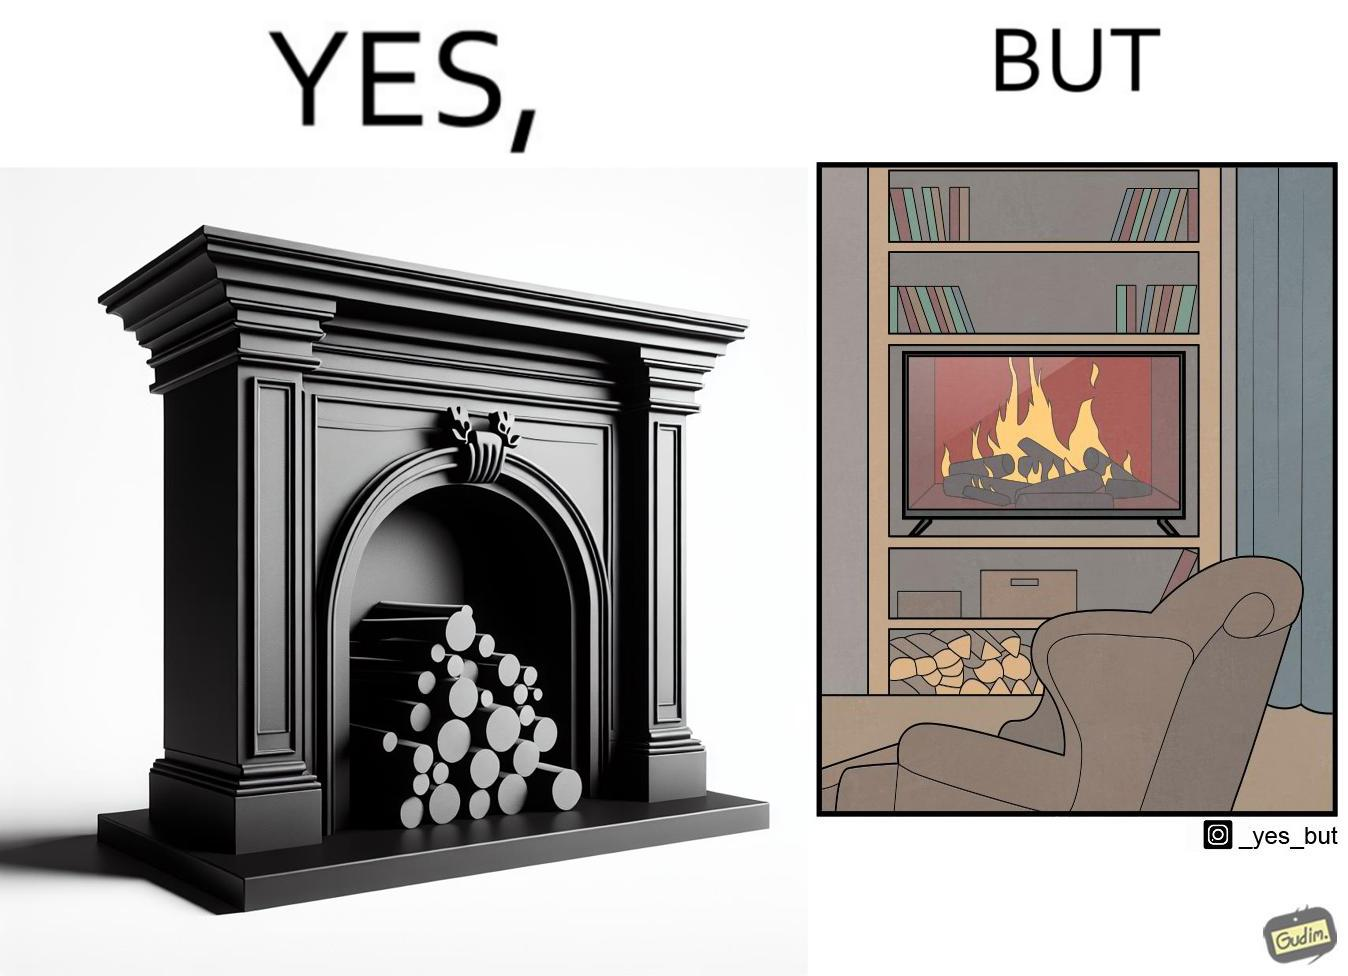What is shown in the left half versus the right half of this image? In the left part of the image: It is a fireplace In the right part of the image: It a fireplace being displayed on a television screen 